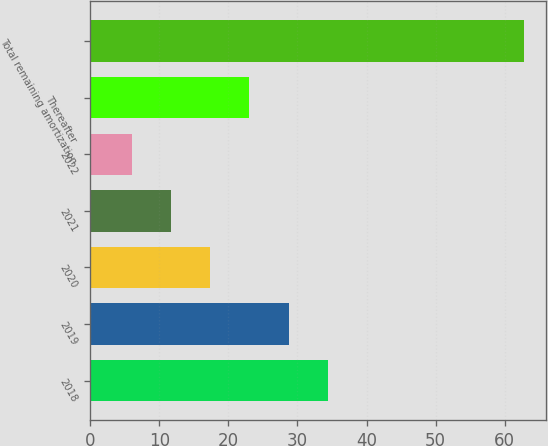Convert chart to OTSL. <chart><loc_0><loc_0><loc_500><loc_500><bar_chart><fcel>2018<fcel>2019<fcel>2020<fcel>2021<fcel>2022<fcel>Thereafter<fcel>Total remaining amortization<nl><fcel>34.4<fcel>28.72<fcel>17.36<fcel>11.68<fcel>6<fcel>23.04<fcel>62.8<nl></chart> 